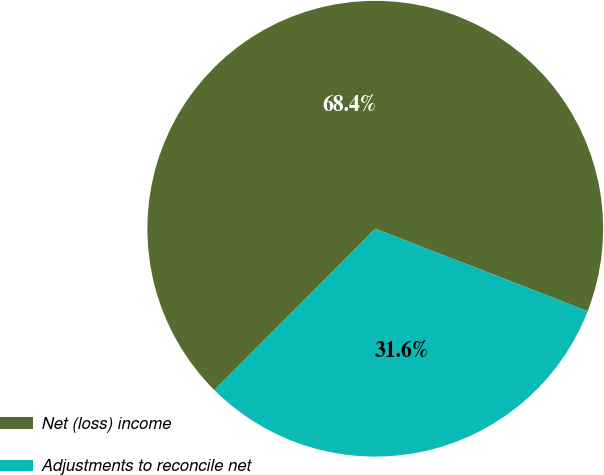Convert chart. <chart><loc_0><loc_0><loc_500><loc_500><pie_chart><fcel>Net (loss) income<fcel>Adjustments to reconcile net<nl><fcel>68.41%<fcel>31.59%<nl></chart> 